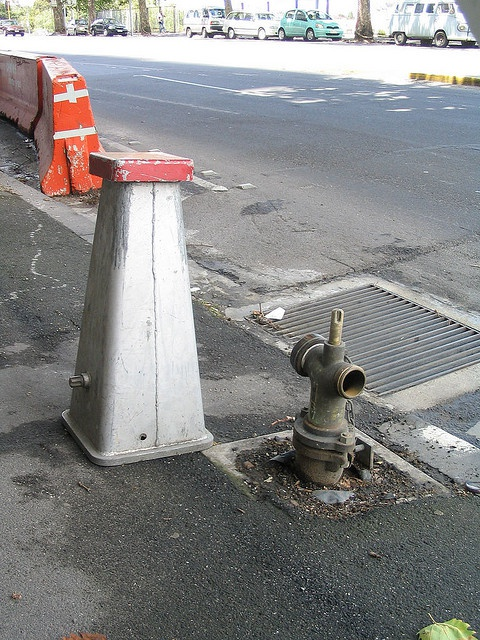Describe the objects in this image and their specific colors. I can see fire hydrant in lavender, black, gray, and darkgray tones, car in lavender, white, darkgray, gray, and lightgray tones, truck in lavender, white, darkgray, gray, and lightgray tones, car in lavender, lightblue, white, darkgray, and gray tones, and car in lavender, white, darkgray, and gray tones in this image. 